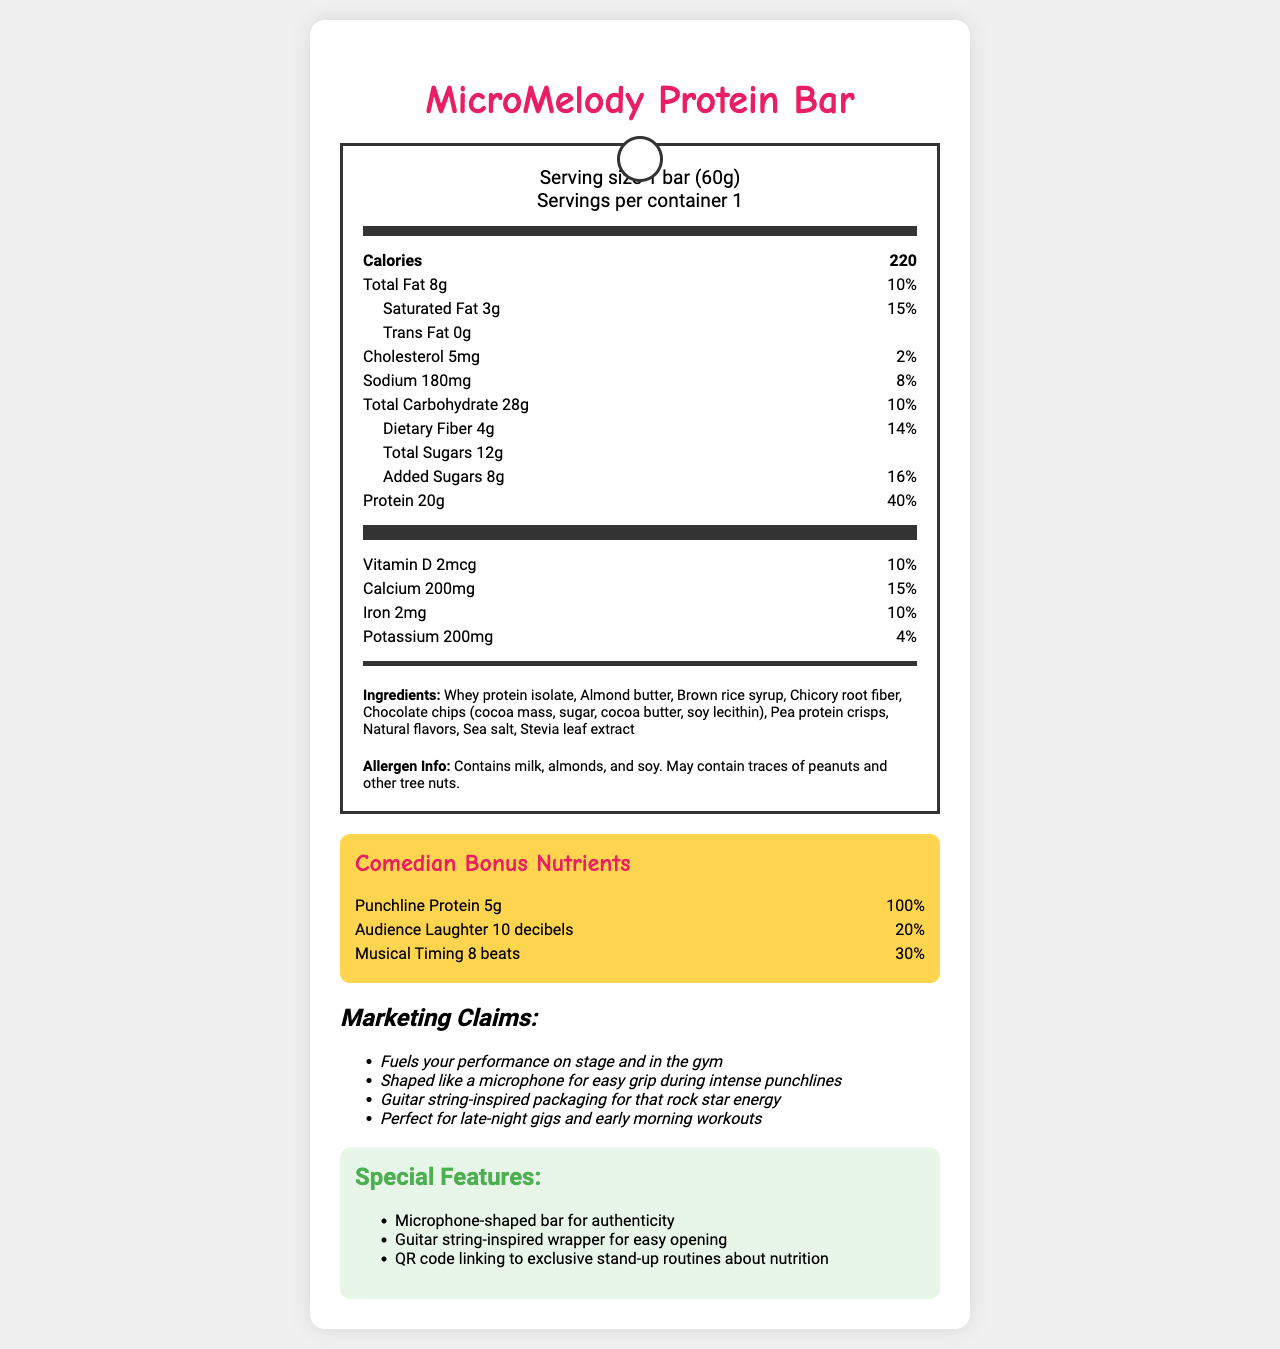What is the serving size of the MicroMelody Protein Bar? The serving size is stated as "1 bar (60g)" in the document.
Answer: 1 bar (60g) How many calories are in one MicroMelody Protein Bar? The document states that there are 220 calories per bar.
Answer: 220 How much protein does the MicroMelody Protein Bar provide per serving? The protein content per serving is listed as 20g in the nutrition facts.
Answer: 20g What is the amount of dietary fiber in the bar, and what is its daily value percentage? The document shows dietary fiber as 4g with a daily value of 14%.
Answer: 4g, 14% Name three ingredients in the MicroMelody Protein Bar. The ingredients list includes Whey protein isolate, Almond butter, Brown rice syrup, among others.
Answer: Whey protein isolate, Almond butter, Brown rice syrup How many grams of added sugars are in the MicroMelody Protein Bar? The document specifies that the bar contains 8g of added sugars.
Answer: 8g Which one of the following is not a special feature of the MicroMelody Protein Bar? A. Guitar-shaped bar B. Microphone-shaped bar C. Guitar string-inspired wrapper The document lists "Microphone-shaped bar" and "Guitar string-inspired wrapper" as special features, but not "Guitar-shaped bar".
Answer: A Which vitamin's daily value percentage is highest in the MicroMelody Protein Bar? A. Vitamin D B. Calcium C. Iron Calcium has a daily value percentage of 15%, which is higher compared to Vitamin D (10%) and Iron (10%).
Answer: B Are there any allergens mentioned in the document? The allergen info section mentions milk, almonds, and soy, and possible traces of peanuts and other tree nuts.
Answer: Yes Does the bar contain any trans fat? The document specifies 0g of trans fat.
Answer: No Summarize the main idea of the document. The document is a comprehensive overview of the MicroMelody Protein Bar, detailing its nutritional information, unique design features, and marketing points, including elements catered specifically to comedians.
Answer: The document presents the nutritional facts, ingredients, allergens, special features, marketing claims, and additional "comedian bonus" nutrients of the MicroMelody Protein Bar. It highlights key details such as the high protein content, unique packaging, and a humorous touch with added nutrients for comedians. What is the source of the chocolate chips in the bar? The document does not provide the source of the chocolate chips used in the bar, only their ingredients.
Answer: I don't know How much sodium is in one MicroMelody Protein Bar? The document states that there is 180mg of sodium in each bar.
Answer: 180mg 